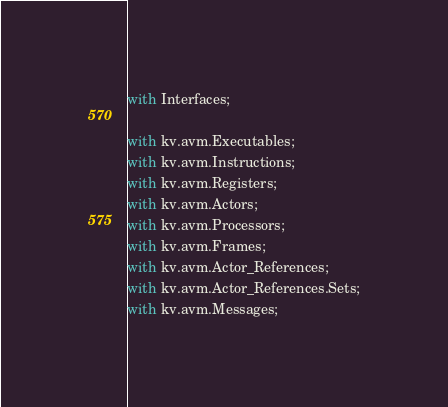Convert code to text. <code><loc_0><loc_0><loc_500><loc_500><_Ada_>with Interfaces;

with kv.avm.Executables;
with kv.avm.Instructions;
with kv.avm.Registers;
with kv.avm.Actors;
with kv.avm.Processors;
with kv.avm.Frames;
with kv.avm.Actor_References;
with kv.avm.Actor_References.Sets;
with kv.avm.Messages;</code> 